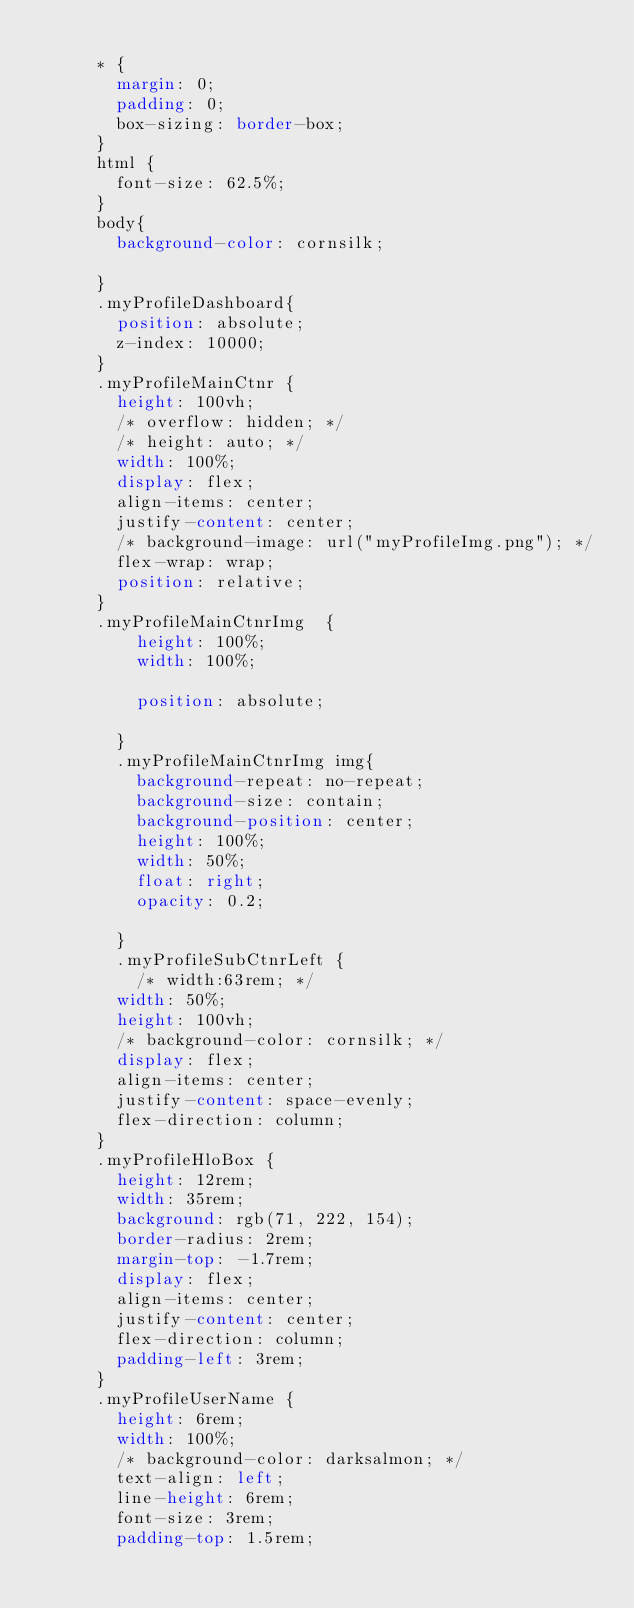<code> <loc_0><loc_0><loc_500><loc_500><_CSS_>
      * {
        margin: 0;
        padding: 0;
        box-sizing: border-box;
      }
      html {
        font-size: 62.5%;
      }
      body{
        background-color: cornsilk;

      }
      .myProfileDashboard{
        position: absolute;
        z-index: 10000;
      }
      .myProfileMainCtnr {
        height: 100vh;
        /* overflow: hidden; */
        /* height: auto; */
        width: 100%;
        display: flex;
        align-items: center;
        justify-content: center;
        /* background-image: url("myProfileImg.png"); */
        flex-wrap: wrap;
        position: relative;
      }
      .myProfileMainCtnrImg  {
          height: 100%;
          width: 100%;
          
          position: absolute;
          
        }
        .myProfileMainCtnrImg img{
          background-repeat: no-repeat;
          background-size: contain;
          background-position: center;
          height: 100%;
          width: 50%;
          float: right;
          opacity: 0.2;

        }
        .myProfileSubCtnrLeft {
          /* width:63rem; */
        width: 50%;
        height: 100vh;
        /* background-color: cornsilk; */
        display: flex;
        align-items: center;
        justify-content: space-evenly;
        flex-direction: column;
      }
      .myProfileHloBox {
        height: 12rem;
        width: 35rem;
        background: rgb(71, 222, 154);
        border-radius: 2rem;
        margin-top: -1.7rem;
        display: flex;
        align-items: center;
        justify-content: center;
        flex-direction: column;
        padding-left: 3rem;
      }
      .myProfileUserName {
        height: 6rem;
        width: 100%;
        /* background-color: darksalmon; */
        text-align: left;
        line-height: 6rem;
        font-size: 3rem;
        padding-top: 1.5rem;</code> 